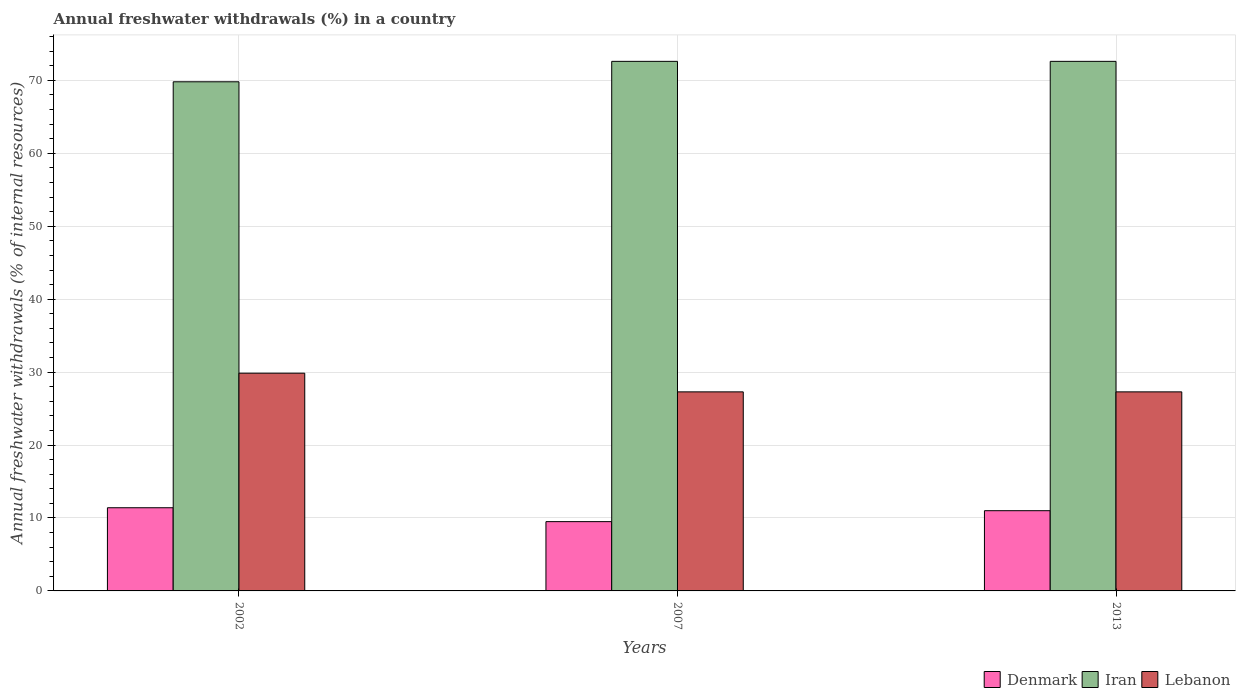Are the number of bars per tick equal to the number of legend labels?
Keep it short and to the point. Yes. Are the number of bars on each tick of the X-axis equal?
Make the answer very short. Yes. What is the percentage of annual freshwater withdrawals in Lebanon in 2013?
Keep it short and to the point. 27.29. Across all years, what is the maximum percentage of annual freshwater withdrawals in Iran?
Give a very brief answer. 72.61. Across all years, what is the minimum percentage of annual freshwater withdrawals in Iran?
Your answer should be compact. 69.81. In which year was the percentage of annual freshwater withdrawals in Lebanon minimum?
Provide a short and direct response. 2007. What is the total percentage of annual freshwater withdrawals in Denmark in the graph?
Your answer should be very brief. 31.9. What is the difference between the percentage of annual freshwater withdrawals in Lebanon in 2007 and that in 2013?
Give a very brief answer. 0. What is the difference between the percentage of annual freshwater withdrawals in Lebanon in 2007 and the percentage of annual freshwater withdrawals in Denmark in 2013?
Offer a very short reply. 16.29. What is the average percentage of annual freshwater withdrawals in Lebanon per year?
Provide a succinct answer. 28.15. In the year 2013, what is the difference between the percentage of annual freshwater withdrawals in Lebanon and percentage of annual freshwater withdrawals in Denmark?
Provide a succinct answer. 16.29. In how many years, is the percentage of annual freshwater withdrawals in Lebanon greater than 58 %?
Provide a succinct answer. 0. What is the ratio of the percentage of annual freshwater withdrawals in Iran in 2007 to that in 2013?
Your answer should be very brief. 1. Is the percentage of annual freshwater withdrawals in Lebanon in 2007 less than that in 2013?
Your response must be concise. No. What is the difference between the highest and the second highest percentage of annual freshwater withdrawals in Denmark?
Offer a very short reply. 0.4. What is the difference between the highest and the lowest percentage of annual freshwater withdrawals in Lebanon?
Your answer should be compact. 2.56. Is the sum of the percentage of annual freshwater withdrawals in Denmark in 2007 and 2013 greater than the maximum percentage of annual freshwater withdrawals in Lebanon across all years?
Make the answer very short. No. What does the 3rd bar from the left in 2002 represents?
Make the answer very short. Lebanon. What does the 2nd bar from the right in 2013 represents?
Your answer should be very brief. Iran. Is it the case that in every year, the sum of the percentage of annual freshwater withdrawals in Denmark and percentage of annual freshwater withdrawals in Lebanon is greater than the percentage of annual freshwater withdrawals in Iran?
Make the answer very short. No. Are all the bars in the graph horizontal?
Your answer should be very brief. No. What is the difference between two consecutive major ticks on the Y-axis?
Provide a short and direct response. 10. Are the values on the major ticks of Y-axis written in scientific E-notation?
Your response must be concise. No. Does the graph contain any zero values?
Keep it short and to the point. No. Does the graph contain grids?
Your response must be concise. Yes. Where does the legend appear in the graph?
Offer a very short reply. Bottom right. What is the title of the graph?
Your answer should be compact. Annual freshwater withdrawals (%) in a country. What is the label or title of the X-axis?
Offer a terse response. Years. What is the label or title of the Y-axis?
Make the answer very short. Annual freshwater withdrawals (% of internal resources). What is the Annual freshwater withdrawals (% of internal resources) in Denmark in 2002?
Give a very brief answer. 11.4. What is the Annual freshwater withdrawals (% of internal resources) of Iran in 2002?
Offer a terse response. 69.81. What is the Annual freshwater withdrawals (% of internal resources) in Lebanon in 2002?
Your answer should be very brief. 29.85. What is the Annual freshwater withdrawals (% of internal resources) of Denmark in 2007?
Provide a short and direct response. 9.5. What is the Annual freshwater withdrawals (% of internal resources) in Iran in 2007?
Ensure brevity in your answer.  72.61. What is the Annual freshwater withdrawals (% of internal resources) in Lebanon in 2007?
Keep it short and to the point. 27.29. What is the Annual freshwater withdrawals (% of internal resources) of Denmark in 2013?
Ensure brevity in your answer.  11. What is the Annual freshwater withdrawals (% of internal resources) in Iran in 2013?
Ensure brevity in your answer.  72.61. What is the Annual freshwater withdrawals (% of internal resources) in Lebanon in 2013?
Your answer should be very brief. 27.29. Across all years, what is the maximum Annual freshwater withdrawals (% of internal resources) of Denmark?
Your response must be concise. 11.4. Across all years, what is the maximum Annual freshwater withdrawals (% of internal resources) in Iran?
Ensure brevity in your answer.  72.61. Across all years, what is the maximum Annual freshwater withdrawals (% of internal resources) in Lebanon?
Provide a succinct answer. 29.85. Across all years, what is the minimum Annual freshwater withdrawals (% of internal resources) in Denmark?
Your answer should be compact. 9.5. Across all years, what is the minimum Annual freshwater withdrawals (% of internal resources) in Iran?
Your answer should be very brief. 69.81. Across all years, what is the minimum Annual freshwater withdrawals (% of internal resources) in Lebanon?
Offer a terse response. 27.29. What is the total Annual freshwater withdrawals (% of internal resources) in Denmark in the graph?
Provide a short and direct response. 31.9. What is the total Annual freshwater withdrawals (% of internal resources) of Iran in the graph?
Ensure brevity in your answer.  215.02. What is the total Annual freshwater withdrawals (% of internal resources) in Lebanon in the graph?
Your answer should be compact. 84.44. What is the difference between the Annual freshwater withdrawals (% of internal resources) in Denmark in 2002 and that in 2007?
Your response must be concise. 1.9. What is the difference between the Annual freshwater withdrawals (% of internal resources) in Iran in 2002 and that in 2007?
Your answer should be compact. -2.8. What is the difference between the Annual freshwater withdrawals (% of internal resources) in Lebanon in 2002 and that in 2007?
Your answer should be very brief. 2.56. What is the difference between the Annual freshwater withdrawals (% of internal resources) of Denmark in 2002 and that in 2013?
Give a very brief answer. 0.4. What is the difference between the Annual freshwater withdrawals (% of internal resources) in Iran in 2002 and that in 2013?
Ensure brevity in your answer.  -2.8. What is the difference between the Annual freshwater withdrawals (% of internal resources) of Lebanon in 2002 and that in 2013?
Offer a very short reply. 2.56. What is the difference between the Annual freshwater withdrawals (% of internal resources) in Denmark in 2002 and the Annual freshwater withdrawals (% of internal resources) in Iran in 2007?
Your answer should be very brief. -61.2. What is the difference between the Annual freshwater withdrawals (% of internal resources) of Denmark in 2002 and the Annual freshwater withdrawals (% of internal resources) of Lebanon in 2007?
Ensure brevity in your answer.  -15.89. What is the difference between the Annual freshwater withdrawals (% of internal resources) in Iran in 2002 and the Annual freshwater withdrawals (% of internal resources) in Lebanon in 2007?
Offer a terse response. 42.51. What is the difference between the Annual freshwater withdrawals (% of internal resources) of Denmark in 2002 and the Annual freshwater withdrawals (% of internal resources) of Iran in 2013?
Offer a terse response. -61.2. What is the difference between the Annual freshwater withdrawals (% of internal resources) of Denmark in 2002 and the Annual freshwater withdrawals (% of internal resources) of Lebanon in 2013?
Your response must be concise. -15.89. What is the difference between the Annual freshwater withdrawals (% of internal resources) in Iran in 2002 and the Annual freshwater withdrawals (% of internal resources) in Lebanon in 2013?
Your response must be concise. 42.51. What is the difference between the Annual freshwater withdrawals (% of internal resources) in Denmark in 2007 and the Annual freshwater withdrawals (% of internal resources) in Iran in 2013?
Ensure brevity in your answer.  -63.11. What is the difference between the Annual freshwater withdrawals (% of internal resources) in Denmark in 2007 and the Annual freshwater withdrawals (% of internal resources) in Lebanon in 2013?
Provide a succinct answer. -17.79. What is the difference between the Annual freshwater withdrawals (% of internal resources) of Iran in 2007 and the Annual freshwater withdrawals (% of internal resources) of Lebanon in 2013?
Give a very brief answer. 45.32. What is the average Annual freshwater withdrawals (% of internal resources) in Denmark per year?
Your answer should be very brief. 10.63. What is the average Annual freshwater withdrawals (% of internal resources) in Iran per year?
Your answer should be compact. 71.67. What is the average Annual freshwater withdrawals (% of internal resources) in Lebanon per year?
Provide a succinct answer. 28.15. In the year 2002, what is the difference between the Annual freshwater withdrawals (% of internal resources) in Denmark and Annual freshwater withdrawals (% of internal resources) in Iran?
Your answer should be very brief. -58.4. In the year 2002, what is the difference between the Annual freshwater withdrawals (% of internal resources) in Denmark and Annual freshwater withdrawals (% of internal resources) in Lebanon?
Provide a succinct answer. -18.45. In the year 2002, what is the difference between the Annual freshwater withdrawals (% of internal resources) of Iran and Annual freshwater withdrawals (% of internal resources) of Lebanon?
Offer a very short reply. 39.95. In the year 2007, what is the difference between the Annual freshwater withdrawals (% of internal resources) in Denmark and Annual freshwater withdrawals (% of internal resources) in Iran?
Give a very brief answer. -63.11. In the year 2007, what is the difference between the Annual freshwater withdrawals (% of internal resources) of Denmark and Annual freshwater withdrawals (% of internal resources) of Lebanon?
Make the answer very short. -17.79. In the year 2007, what is the difference between the Annual freshwater withdrawals (% of internal resources) of Iran and Annual freshwater withdrawals (% of internal resources) of Lebanon?
Give a very brief answer. 45.32. In the year 2013, what is the difference between the Annual freshwater withdrawals (% of internal resources) of Denmark and Annual freshwater withdrawals (% of internal resources) of Iran?
Make the answer very short. -61.61. In the year 2013, what is the difference between the Annual freshwater withdrawals (% of internal resources) in Denmark and Annual freshwater withdrawals (% of internal resources) in Lebanon?
Provide a short and direct response. -16.29. In the year 2013, what is the difference between the Annual freshwater withdrawals (% of internal resources) of Iran and Annual freshwater withdrawals (% of internal resources) of Lebanon?
Offer a terse response. 45.32. What is the ratio of the Annual freshwater withdrawals (% of internal resources) of Denmark in 2002 to that in 2007?
Offer a terse response. 1.2. What is the ratio of the Annual freshwater withdrawals (% of internal resources) in Iran in 2002 to that in 2007?
Your answer should be compact. 0.96. What is the ratio of the Annual freshwater withdrawals (% of internal resources) in Lebanon in 2002 to that in 2007?
Give a very brief answer. 1.09. What is the ratio of the Annual freshwater withdrawals (% of internal resources) of Denmark in 2002 to that in 2013?
Offer a very short reply. 1.04. What is the ratio of the Annual freshwater withdrawals (% of internal resources) of Iran in 2002 to that in 2013?
Provide a succinct answer. 0.96. What is the ratio of the Annual freshwater withdrawals (% of internal resources) in Lebanon in 2002 to that in 2013?
Keep it short and to the point. 1.09. What is the ratio of the Annual freshwater withdrawals (% of internal resources) in Denmark in 2007 to that in 2013?
Provide a succinct answer. 0.86. What is the ratio of the Annual freshwater withdrawals (% of internal resources) in Iran in 2007 to that in 2013?
Provide a short and direct response. 1. What is the ratio of the Annual freshwater withdrawals (% of internal resources) of Lebanon in 2007 to that in 2013?
Offer a terse response. 1. What is the difference between the highest and the second highest Annual freshwater withdrawals (% of internal resources) of Denmark?
Your answer should be very brief. 0.4. What is the difference between the highest and the second highest Annual freshwater withdrawals (% of internal resources) of Lebanon?
Offer a terse response. 2.56. What is the difference between the highest and the lowest Annual freshwater withdrawals (% of internal resources) in Denmark?
Ensure brevity in your answer.  1.9. What is the difference between the highest and the lowest Annual freshwater withdrawals (% of internal resources) of Iran?
Your response must be concise. 2.8. What is the difference between the highest and the lowest Annual freshwater withdrawals (% of internal resources) in Lebanon?
Offer a very short reply. 2.56. 